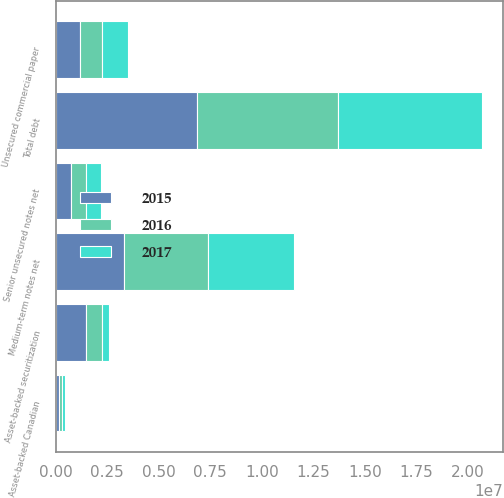Convert chart. <chart><loc_0><loc_0><loc_500><loc_500><stacked_bar_chart><ecel><fcel>Unsecured commercial paper<fcel>Asset-backed Canadian<fcel>Medium-term notes net<fcel>Senior unsecured notes net<fcel>Asset-backed securitization<fcel>Total debt<nl><fcel>2017<fcel>1.27348e+06<fcel>174779<fcel>4.16571e+06<fcel>741961<fcel>352624<fcel>6.98801e+06<nl><fcel>2016<fcel>1.05571e+06<fcel>149338<fcel>4.06494e+06<fcel>741306<fcel>796275<fcel>6.80757e+06<nl><fcel>2015<fcel>1.20138e+06<fcel>153839<fcel>3.31695e+06<fcel>740653<fcel>1.45938e+06<fcel>6.8722e+06<nl></chart> 